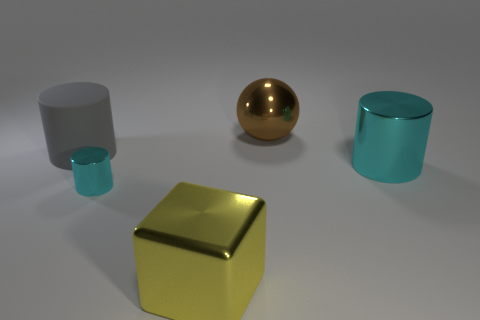There is a yellow object that is made of the same material as the big brown ball; what shape is it?
Provide a short and direct response. Cube. Do the gray cylinder and the small thing have the same material?
Your answer should be compact. No. Is there any other thing that is made of the same material as the gray cylinder?
Offer a very short reply. No. There is another tiny object that is the same shape as the gray object; what is it made of?
Ensure brevity in your answer.  Metal. Is the number of cylinders behind the brown sphere less than the number of large gray matte cylinders?
Your answer should be very brief. Yes. What number of tiny metallic cylinders are to the left of the big cyan metallic cylinder?
Keep it short and to the point. 1. Is the shape of the large shiny thing behind the rubber object the same as the big cyan shiny object that is on the right side of the cube?
Your answer should be compact. No. The big metal object that is on the left side of the big cyan shiny cylinder and in front of the brown object has what shape?
Offer a very short reply. Cube. The yellow thing that is made of the same material as the large sphere is what size?
Offer a terse response. Large. Is the number of cyan cylinders less than the number of tiny brown things?
Give a very brief answer. No. 